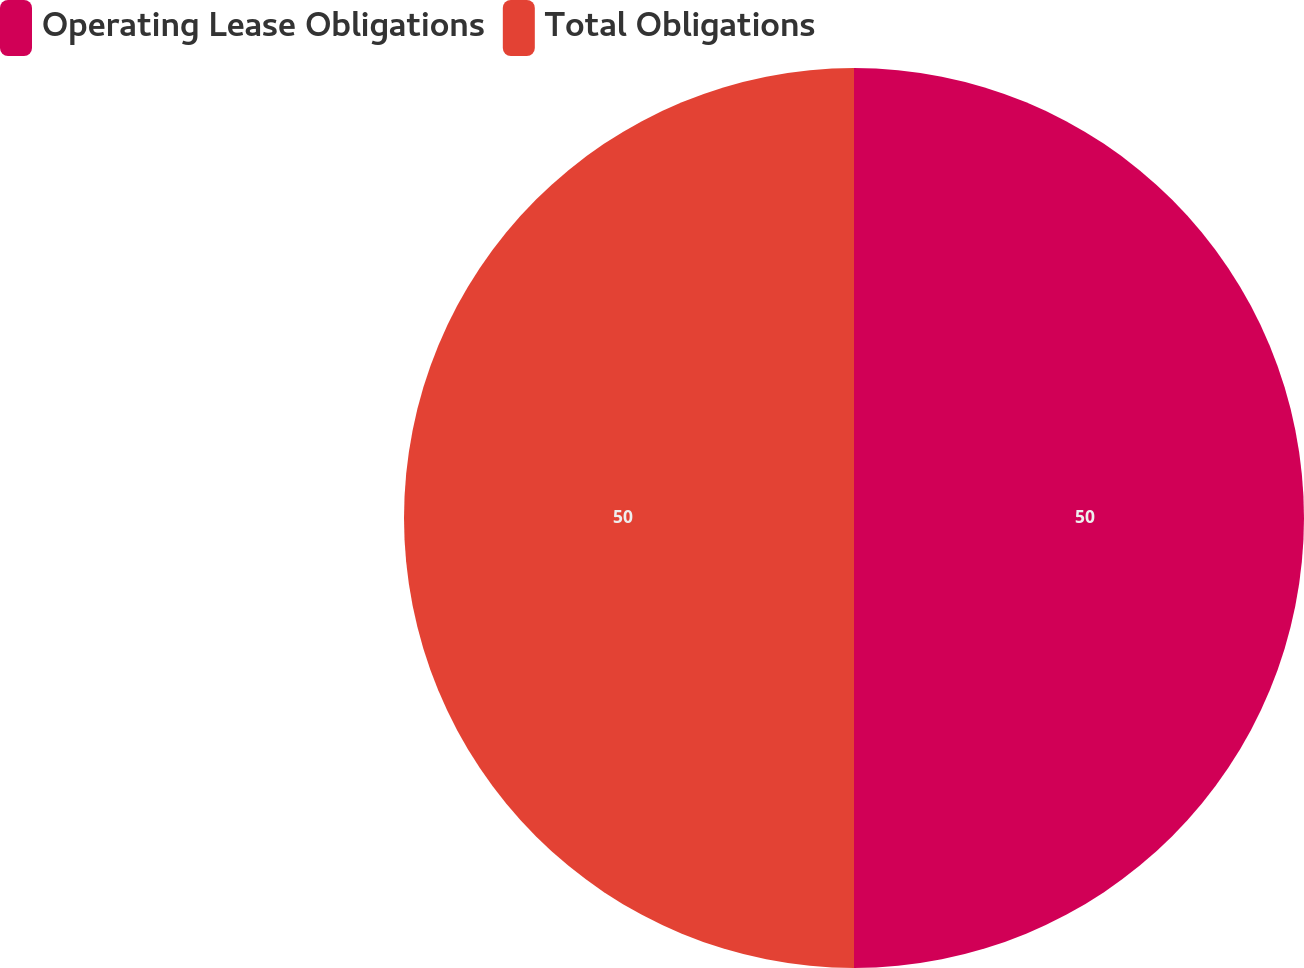<chart> <loc_0><loc_0><loc_500><loc_500><pie_chart><fcel>Operating Lease Obligations<fcel>Total Obligations<nl><fcel>50.0%<fcel>50.0%<nl></chart> 